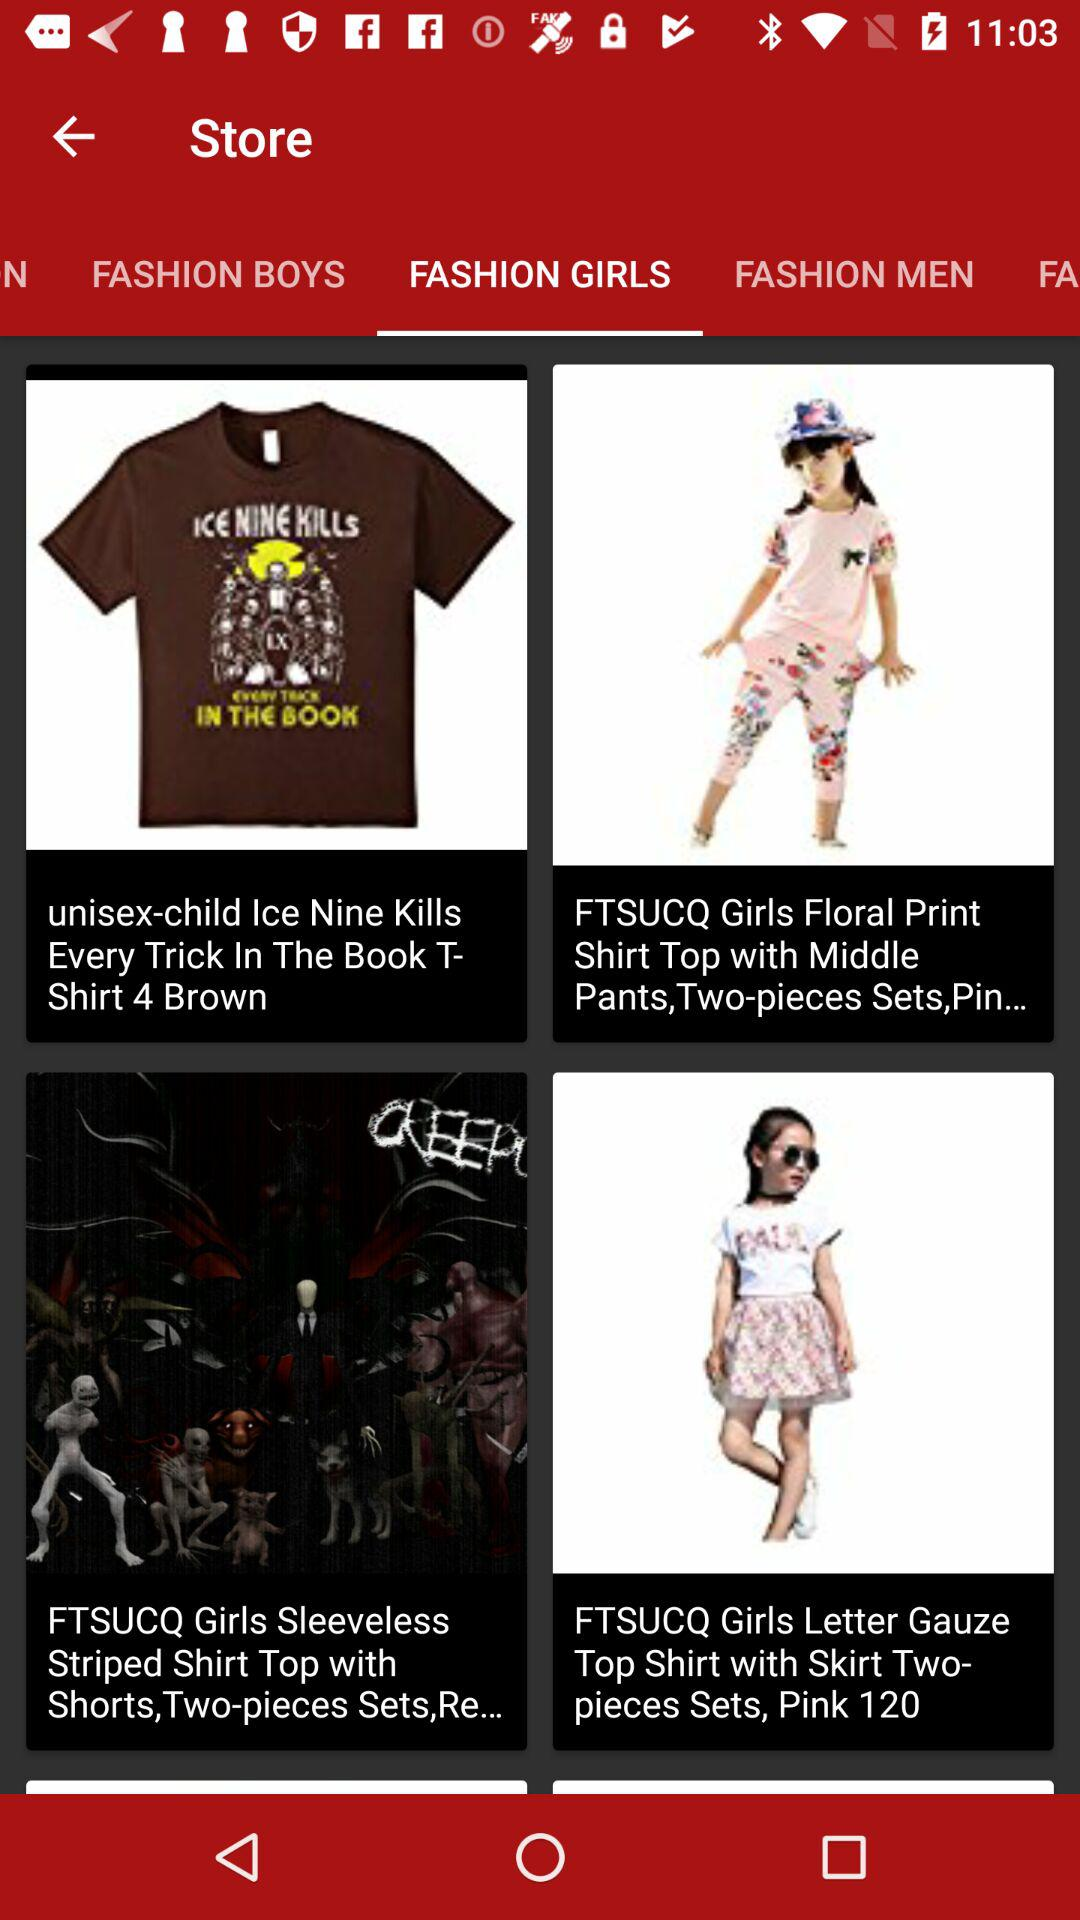Which option is selected in "Store"? The selected option in "Store" is "FASHION GIRLS". 